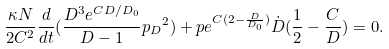Convert formula to latex. <formula><loc_0><loc_0><loc_500><loc_500>\frac { \kappa N } { 2 C ^ { 2 } } \frac { d } { d t } ( \frac { D ^ { 3 } e ^ { C D / D _ { 0 } } } { D - 1 } { p _ { D } } ^ { 2 } ) + p e ^ { C ( 2 - \frac { D } { D _ { 0 } } ) } \dot { D } ( \frac { 1 } { 2 } - \frac { C } { D } ) = 0 .</formula> 